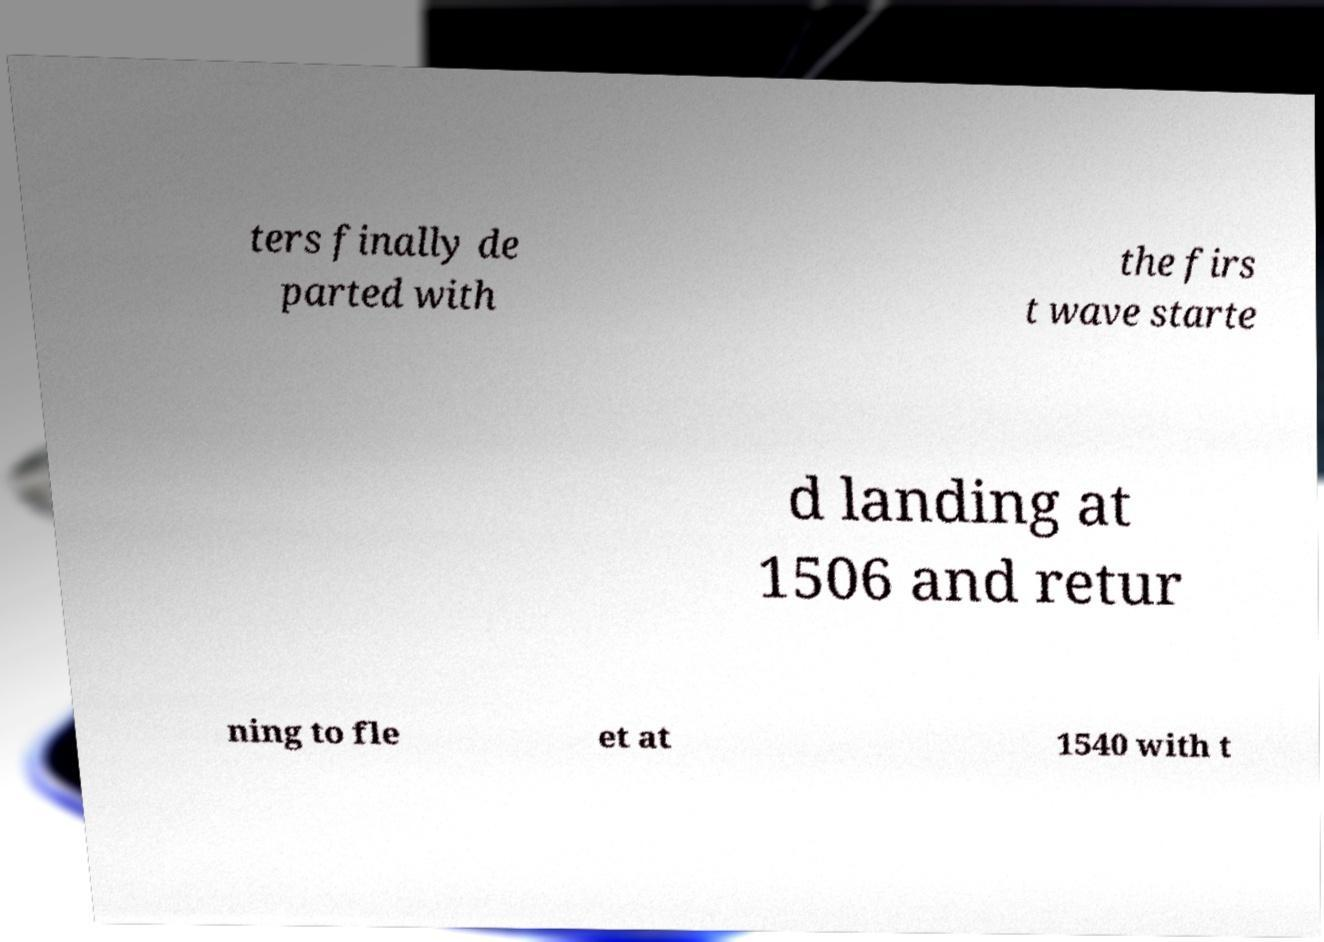For documentation purposes, I need the text within this image transcribed. Could you provide that? ters finally de parted with the firs t wave starte d landing at 1506 and retur ning to fle et at 1540 with t 